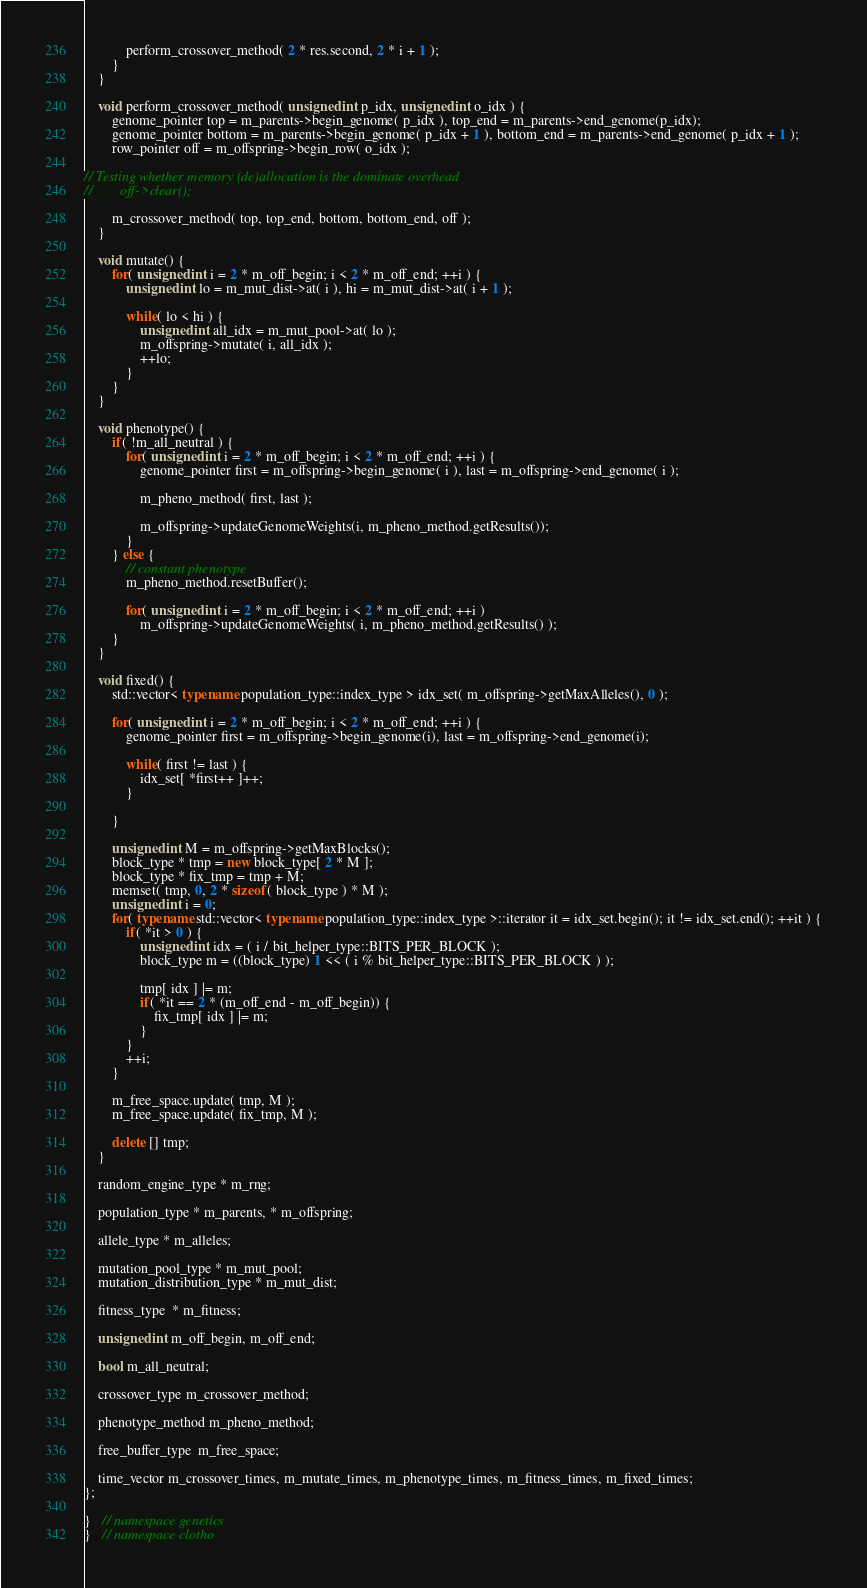<code> <loc_0><loc_0><loc_500><loc_500><_C++_>            perform_crossover_method( 2 * res.second, 2 * i + 1 );
        }
    }

    void perform_crossover_method( unsigned int p_idx, unsigned int o_idx ) {
        genome_pointer top = m_parents->begin_genome( p_idx ), top_end = m_parents->end_genome(p_idx);
        genome_pointer bottom = m_parents->begin_genome( p_idx + 1 ), bottom_end = m_parents->end_genome( p_idx + 1 );
        row_pointer off = m_offspring->begin_row( o_idx );

// Testing whether memory (de)allocation is the dominate overhead
//        off->clear();

        m_crossover_method( top, top_end, bottom, bottom_end, off ); 
    }

    void mutate() {
        for( unsigned int i = 2 * m_off_begin; i < 2 * m_off_end; ++i ) {
            unsigned int lo = m_mut_dist->at( i ), hi = m_mut_dist->at( i + 1 );

            while( lo < hi ) {
                unsigned int all_idx = m_mut_pool->at( lo );
                m_offspring->mutate( i, all_idx );
                ++lo;
            }
        } 
    }

    void phenotype() {
        if( !m_all_neutral ) {
            for( unsigned int i = 2 * m_off_begin; i < 2 * m_off_end; ++i ) {
                genome_pointer first = m_offspring->begin_genome( i ), last = m_offspring->end_genome( i );

                m_pheno_method( first, last );

                m_offspring->updateGenomeWeights(i, m_pheno_method.getResults());
            }
        } else {
            // constant phenotype
            m_pheno_method.resetBuffer();

            for( unsigned int i = 2 * m_off_begin; i < 2 * m_off_end; ++i )
                m_offspring->updateGenomeWeights( i, m_pheno_method.getResults() ); 
        }
    }

    void fixed() {
        std::vector< typename population_type::index_type > idx_set( m_offspring->getMaxAlleles(), 0 );

        for( unsigned int i = 2 * m_off_begin; i < 2 * m_off_end; ++i ) {
            genome_pointer first = m_offspring->begin_genome(i), last = m_offspring->end_genome(i);

            while( first != last ) {
                idx_set[ *first++ ]++;
            }

        }

        unsigned int M = m_offspring->getMaxBlocks();
        block_type * tmp = new block_type[ 2 * M ];
        block_type * fix_tmp = tmp + M;
        memset( tmp, 0, 2 * sizeof( block_type ) * M );
        unsigned int i = 0;
        for( typename std::vector< typename population_type::index_type >::iterator it = idx_set.begin(); it != idx_set.end(); ++it ) {
            if( *it > 0 ) {
                unsigned int idx = ( i / bit_helper_type::BITS_PER_BLOCK );
                block_type m = ((block_type) 1 << ( i % bit_helper_type::BITS_PER_BLOCK ) );

                tmp[ idx ] |= m;
                if( *it == 2 * (m_off_end - m_off_begin)) {
                    fix_tmp[ idx ] |= m;
                }
            }
            ++i;
        }

        m_free_space.update( tmp, M );
        m_free_space.update( fix_tmp, M );

        delete [] tmp;
    }

    random_engine_type * m_rng;

    population_type * m_parents, * m_offspring;

    allele_type * m_alleles;

    mutation_pool_type * m_mut_pool;
    mutation_distribution_type * m_mut_dist;

    fitness_type  * m_fitness;

    unsigned int m_off_begin, m_off_end;

    bool m_all_neutral;

    crossover_type m_crossover_method;

    phenotype_method m_pheno_method;
    
    free_buffer_type  m_free_space;

    time_vector m_crossover_times, m_mutate_times, m_phenotype_times, m_fitness_times, m_fixed_times;
};

}   // namespace genetics
}   // namespace clotho
</code> 